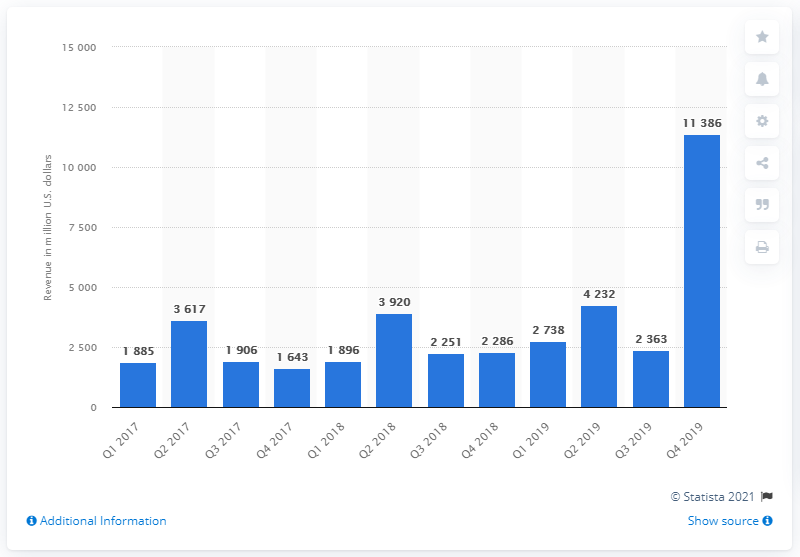List a handful of essential elements in this visual. In the fourth quarter of 2019, the gaming revenue of Microsoft was 11,386. 